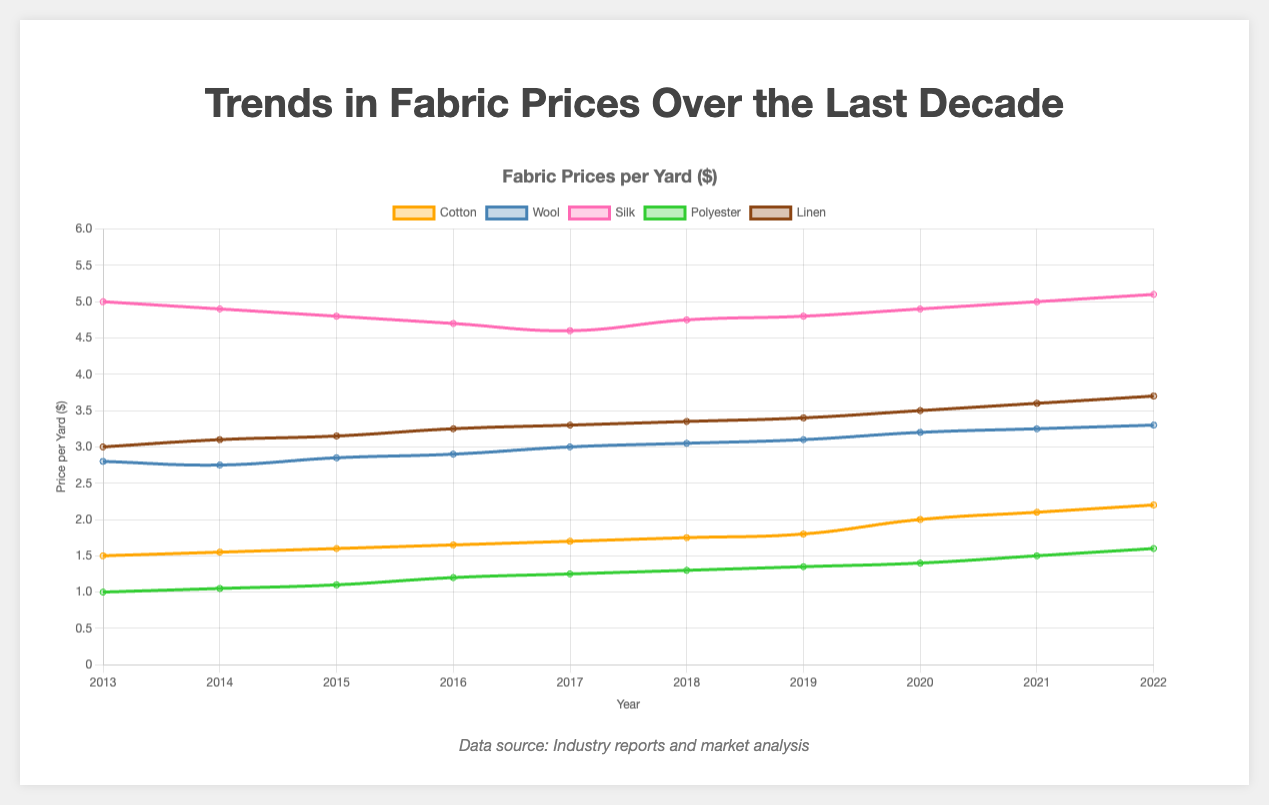What is the general trend in the price of cotton from 2013 to 2022? The price of cotton shows a steady increase over the years from 1.50 in 2013 to 2.20 in 2022.
Answer: Increased Which year had the highest price for silk? By checking the graph, we see that the price of silk was highest in 2022 at 5.10.
Answer: 2022 How much did the price of wool increase from 2016 to 2022? The price of wool in 2016 was 2.90 and in 2022 it was 3.30. The increase is 3.30 - 2.90 = 0.40.
Answer: 0.40 Which fabric had the most stable price trend over the decade? Silk had the most stable price trend, with minor fluctuations and the range from 4.60 to 5.10.
Answer: Silk When did polyester's price surpass $1.50 per yard for the first time? The price of polyester surpassed $1.50 for the first time in the year 2021.
Answer: 2021 What was the average price of linen from 2013 to 2017? The prices are 3.00, 3.10, 3.15, 3.25, 3.30. So, the average is (3.00 + 3.10 + 3.15 + 3.25 + 3.30) / 5 = 3.16.
Answer: 3.16 Compare the price growth trends of cotton and polyester from 2013 to 2022. Cotton increased steadily from 1.50 to 2.20, while polyester increased more gradually from 1.00 to 1.60. Both trends are upward but cotton had a higher overall increase.
Answer: Cotton grew more In which year was the price gap between cotton and polyester the smallest? By comparing the lines, the smallest gap was in 2021 when the prices were the closest, 2.10 for cotton and 1.50 for polyester.
Answer: 2021 Which fabric showed the greatest percentage increase from 2013 to 2022? Cotton increased from 1.50 to 2.20, an increase of (2.20-1.50)/1.50 = 46.7%. Polyester increased from 1.00 to 1.60, an increase of 60%. Polyester had the greatest percentage increase.
Answer: Polyester 